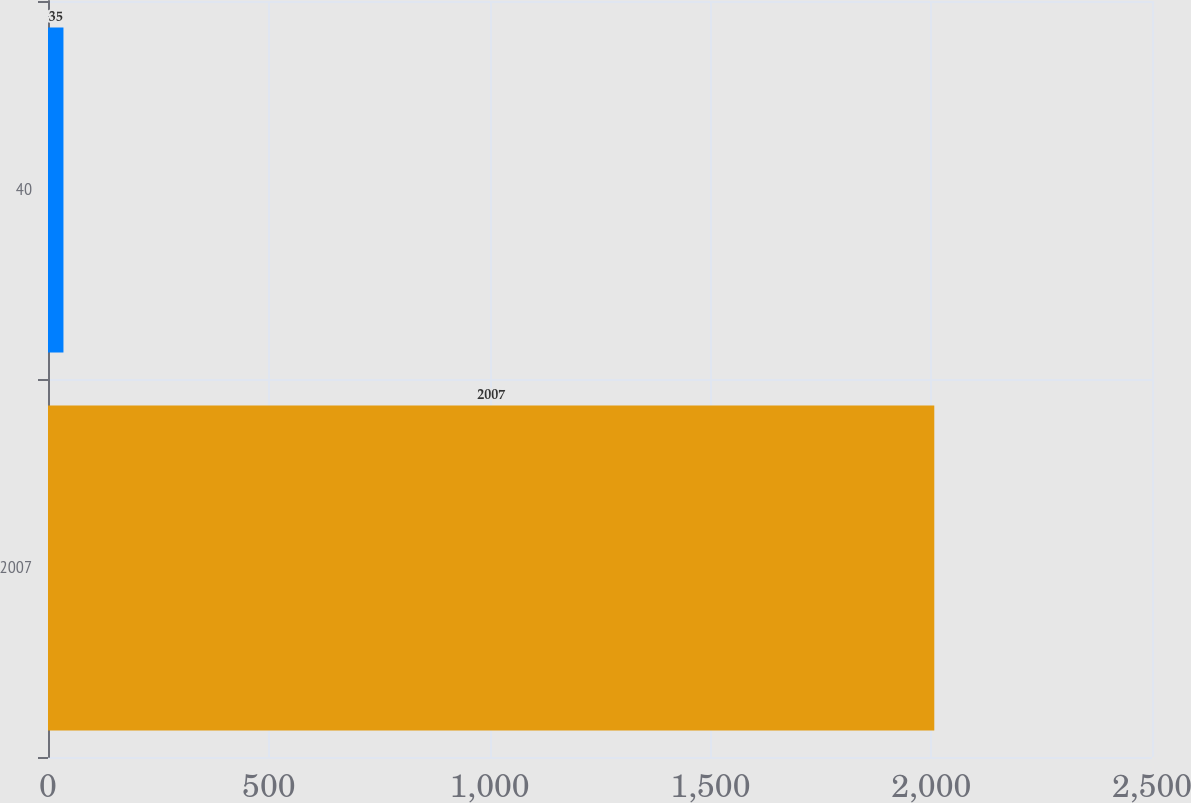Convert chart to OTSL. <chart><loc_0><loc_0><loc_500><loc_500><bar_chart><fcel>2007<fcel>40<nl><fcel>2007<fcel>35<nl></chart> 